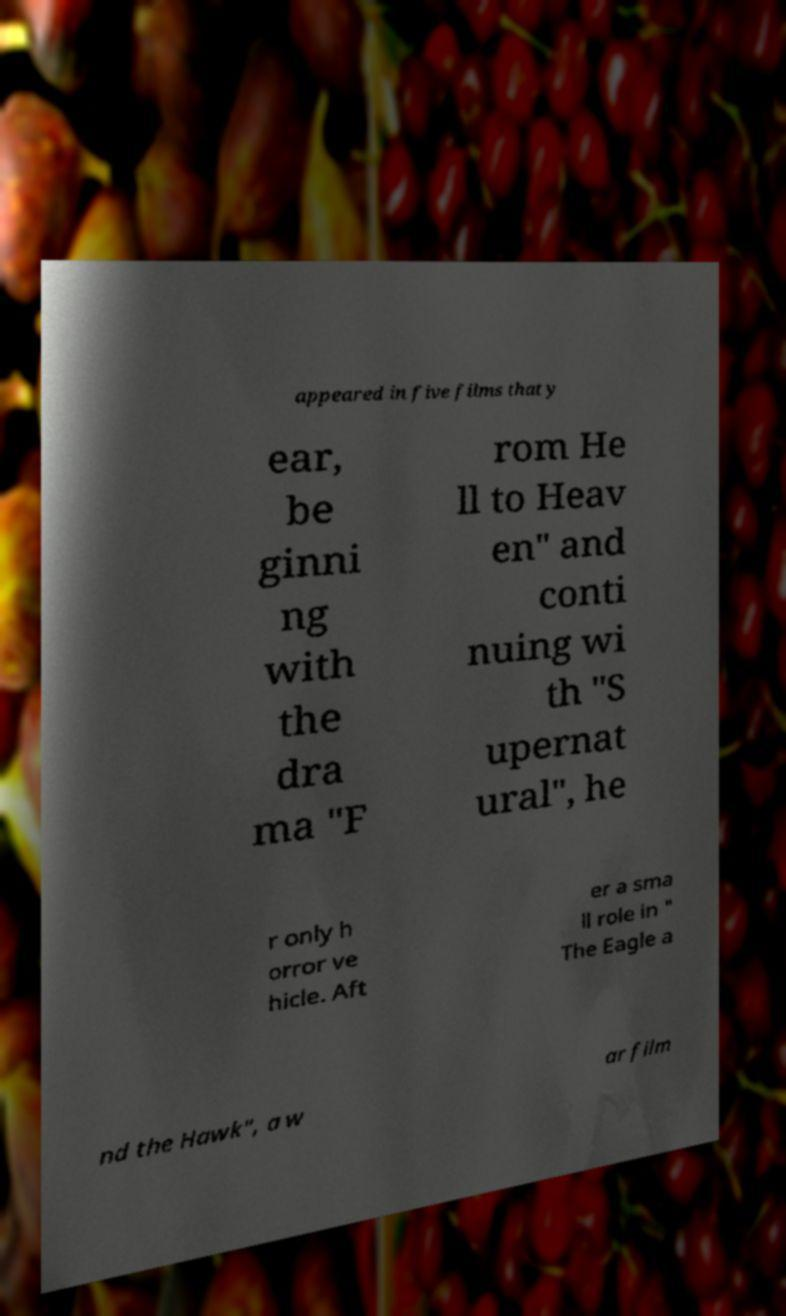Can you accurately transcribe the text from the provided image for me? appeared in five films that y ear, be ginni ng with the dra ma "F rom He ll to Heav en" and conti nuing wi th "S upernat ural", he r only h orror ve hicle. Aft er a sma ll role in " The Eagle a nd the Hawk", a w ar film 